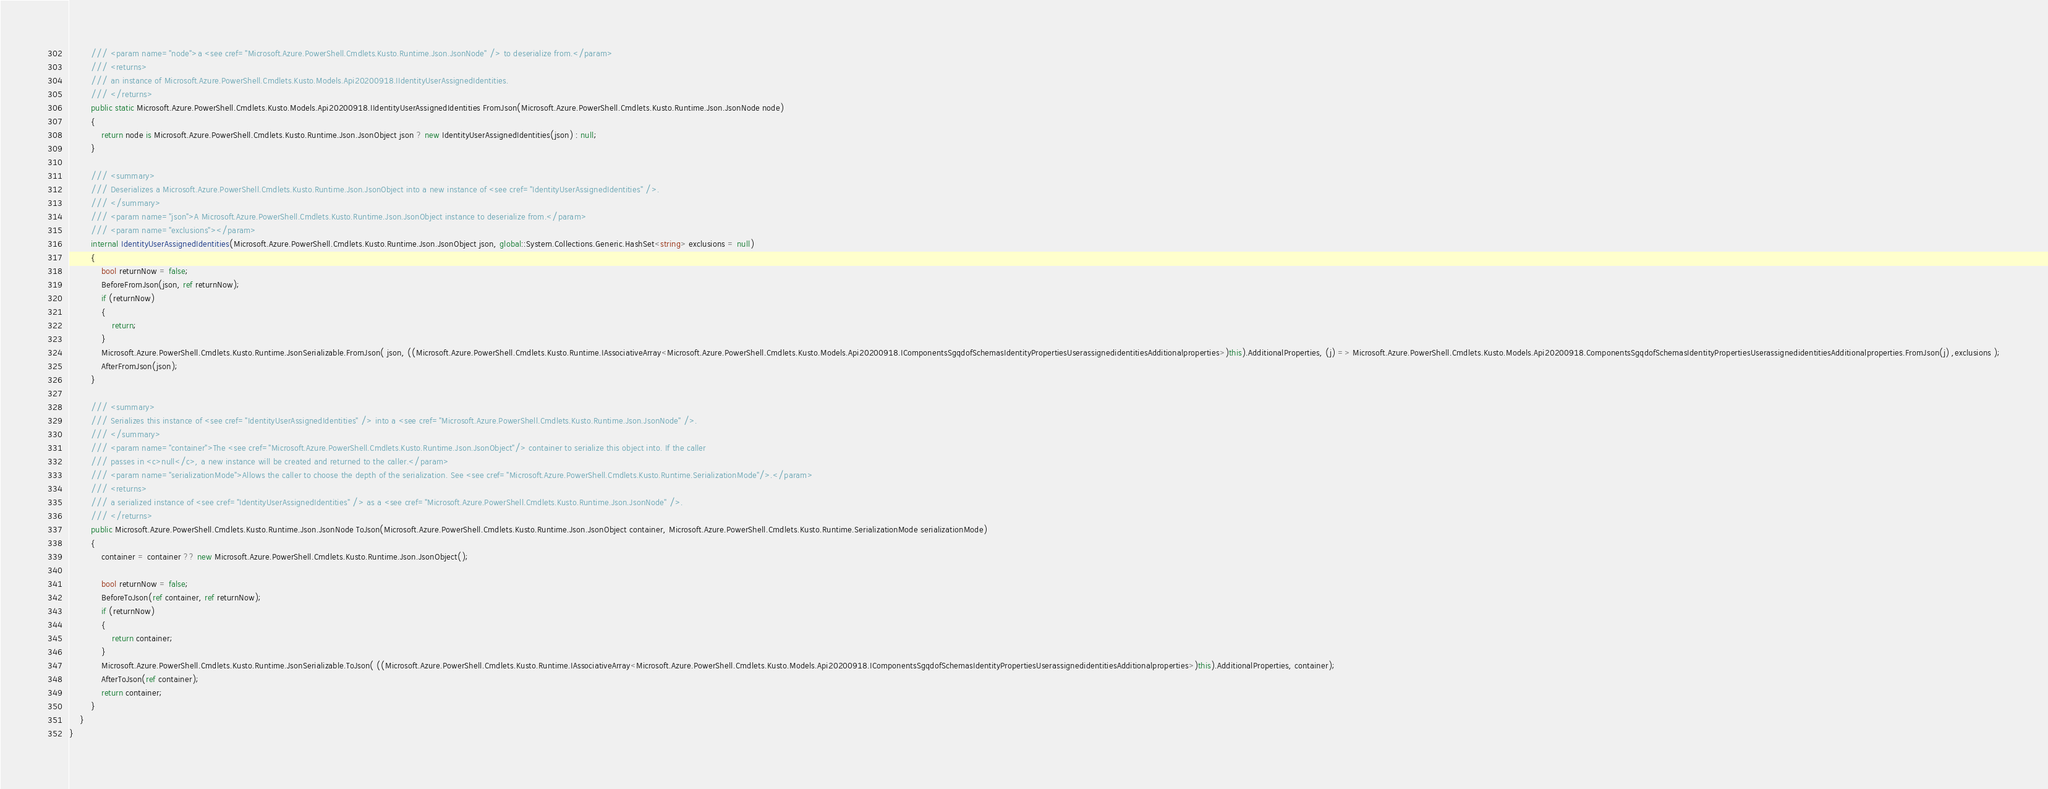<code> <loc_0><loc_0><loc_500><loc_500><_C#_>        /// <param name="node">a <see cref="Microsoft.Azure.PowerShell.Cmdlets.Kusto.Runtime.Json.JsonNode" /> to deserialize from.</param>
        /// <returns>
        /// an instance of Microsoft.Azure.PowerShell.Cmdlets.Kusto.Models.Api20200918.IIdentityUserAssignedIdentities.
        /// </returns>
        public static Microsoft.Azure.PowerShell.Cmdlets.Kusto.Models.Api20200918.IIdentityUserAssignedIdentities FromJson(Microsoft.Azure.PowerShell.Cmdlets.Kusto.Runtime.Json.JsonNode node)
        {
            return node is Microsoft.Azure.PowerShell.Cmdlets.Kusto.Runtime.Json.JsonObject json ? new IdentityUserAssignedIdentities(json) : null;
        }

        /// <summary>
        /// Deserializes a Microsoft.Azure.PowerShell.Cmdlets.Kusto.Runtime.Json.JsonObject into a new instance of <see cref="IdentityUserAssignedIdentities" />.
        /// </summary>
        /// <param name="json">A Microsoft.Azure.PowerShell.Cmdlets.Kusto.Runtime.Json.JsonObject instance to deserialize from.</param>
        /// <param name="exclusions"></param>
        internal IdentityUserAssignedIdentities(Microsoft.Azure.PowerShell.Cmdlets.Kusto.Runtime.Json.JsonObject json, global::System.Collections.Generic.HashSet<string> exclusions = null)
        {
            bool returnNow = false;
            BeforeFromJson(json, ref returnNow);
            if (returnNow)
            {
                return;
            }
            Microsoft.Azure.PowerShell.Cmdlets.Kusto.Runtime.JsonSerializable.FromJson( json, ((Microsoft.Azure.PowerShell.Cmdlets.Kusto.Runtime.IAssociativeArray<Microsoft.Azure.PowerShell.Cmdlets.Kusto.Models.Api20200918.IComponentsSgqdofSchemasIdentityPropertiesUserassignedidentitiesAdditionalproperties>)this).AdditionalProperties, (j) => Microsoft.Azure.PowerShell.Cmdlets.Kusto.Models.Api20200918.ComponentsSgqdofSchemasIdentityPropertiesUserassignedidentitiesAdditionalproperties.FromJson(j) ,exclusions );
            AfterFromJson(json);
        }

        /// <summary>
        /// Serializes this instance of <see cref="IdentityUserAssignedIdentities" /> into a <see cref="Microsoft.Azure.PowerShell.Cmdlets.Kusto.Runtime.Json.JsonNode" />.
        /// </summary>
        /// <param name="container">The <see cref="Microsoft.Azure.PowerShell.Cmdlets.Kusto.Runtime.Json.JsonObject"/> container to serialize this object into. If the caller
        /// passes in <c>null</c>, a new instance will be created and returned to the caller.</param>
        /// <param name="serializationMode">Allows the caller to choose the depth of the serialization. See <see cref="Microsoft.Azure.PowerShell.Cmdlets.Kusto.Runtime.SerializationMode"/>.</param>
        /// <returns>
        /// a serialized instance of <see cref="IdentityUserAssignedIdentities" /> as a <see cref="Microsoft.Azure.PowerShell.Cmdlets.Kusto.Runtime.Json.JsonNode" />.
        /// </returns>
        public Microsoft.Azure.PowerShell.Cmdlets.Kusto.Runtime.Json.JsonNode ToJson(Microsoft.Azure.PowerShell.Cmdlets.Kusto.Runtime.Json.JsonObject container, Microsoft.Azure.PowerShell.Cmdlets.Kusto.Runtime.SerializationMode serializationMode)
        {
            container = container ?? new Microsoft.Azure.PowerShell.Cmdlets.Kusto.Runtime.Json.JsonObject();

            bool returnNow = false;
            BeforeToJson(ref container, ref returnNow);
            if (returnNow)
            {
                return container;
            }
            Microsoft.Azure.PowerShell.Cmdlets.Kusto.Runtime.JsonSerializable.ToJson( ((Microsoft.Azure.PowerShell.Cmdlets.Kusto.Runtime.IAssociativeArray<Microsoft.Azure.PowerShell.Cmdlets.Kusto.Models.Api20200918.IComponentsSgqdofSchemasIdentityPropertiesUserassignedidentitiesAdditionalproperties>)this).AdditionalProperties, container);
            AfterToJson(ref container);
            return container;
        }
    }
}</code> 